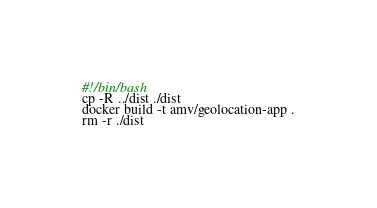Convert code to text. <code><loc_0><loc_0><loc_500><loc_500><_Bash_>#!/bin/bash
cp -R ../dist ./dist
docker build -t amv/geolocation-app .
rm -r ./dist
</code> 